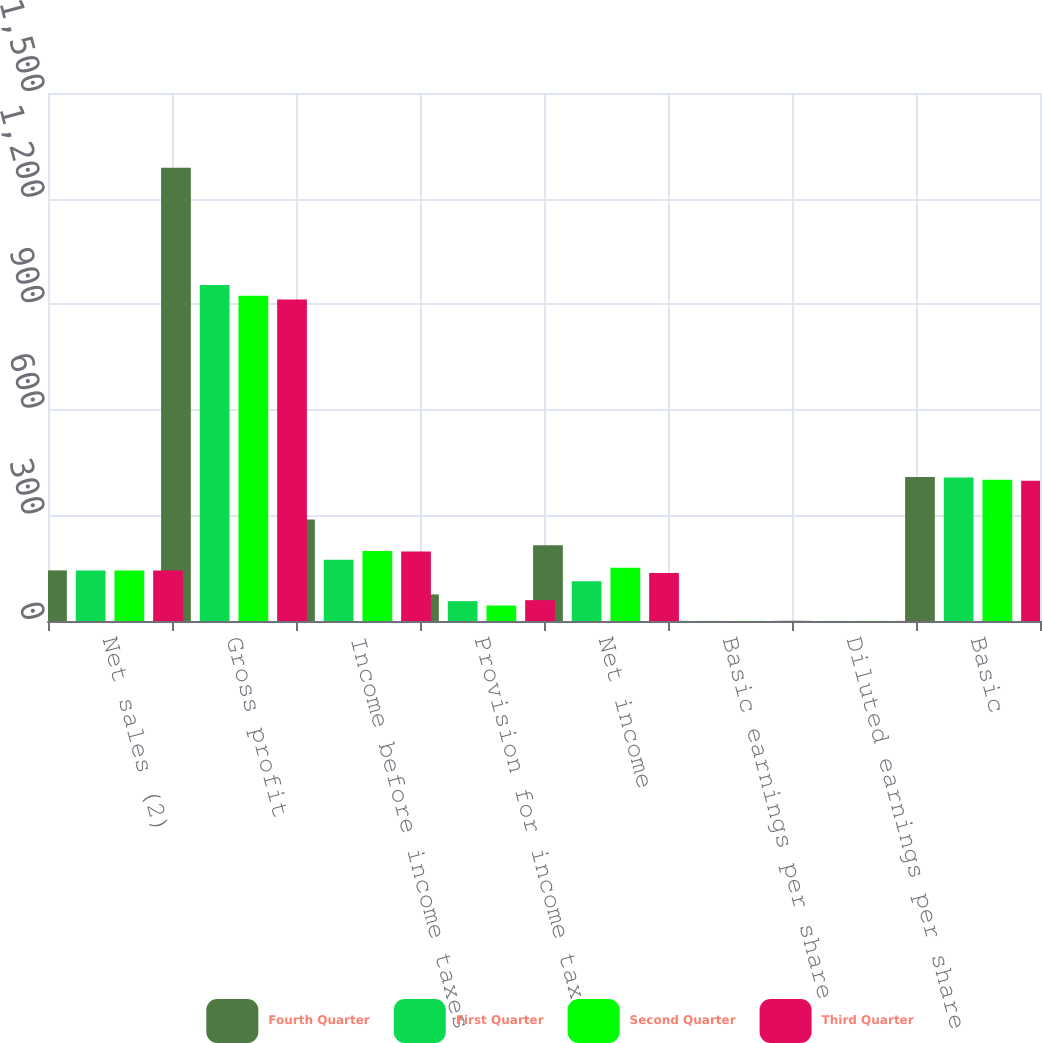<chart> <loc_0><loc_0><loc_500><loc_500><stacked_bar_chart><ecel><fcel>Net sales (2)<fcel>Gross profit<fcel>Income before income taxes<fcel>Provision for income taxes<fcel>Net income<fcel>Basic earnings per share<fcel>Diluted earnings per share<fcel>Basic<nl><fcel>Fourth Quarter<fcel>150.5<fcel>1348<fcel>302<fcel>79<fcel>225<fcel>0.52<fcel>0.52<fcel>428<nl><fcel>First Quarter<fcel>150.5<fcel>999<fcel>182<fcel>59<fcel>118<fcel>0.28<fcel>0.27<fcel>427<nl><fcel>Second Quarter<fcel>150.5<fcel>967<fcel>208<fcel>46<fcel>158<fcel>0.38<fcel>0.37<fcel>420<nl><fcel>Third Quarter<fcel>150.5<fcel>956<fcel>207<fcel>62<fcel>143<fcel>0.34<fcel>0.34<fcel>417<nl></chart> 